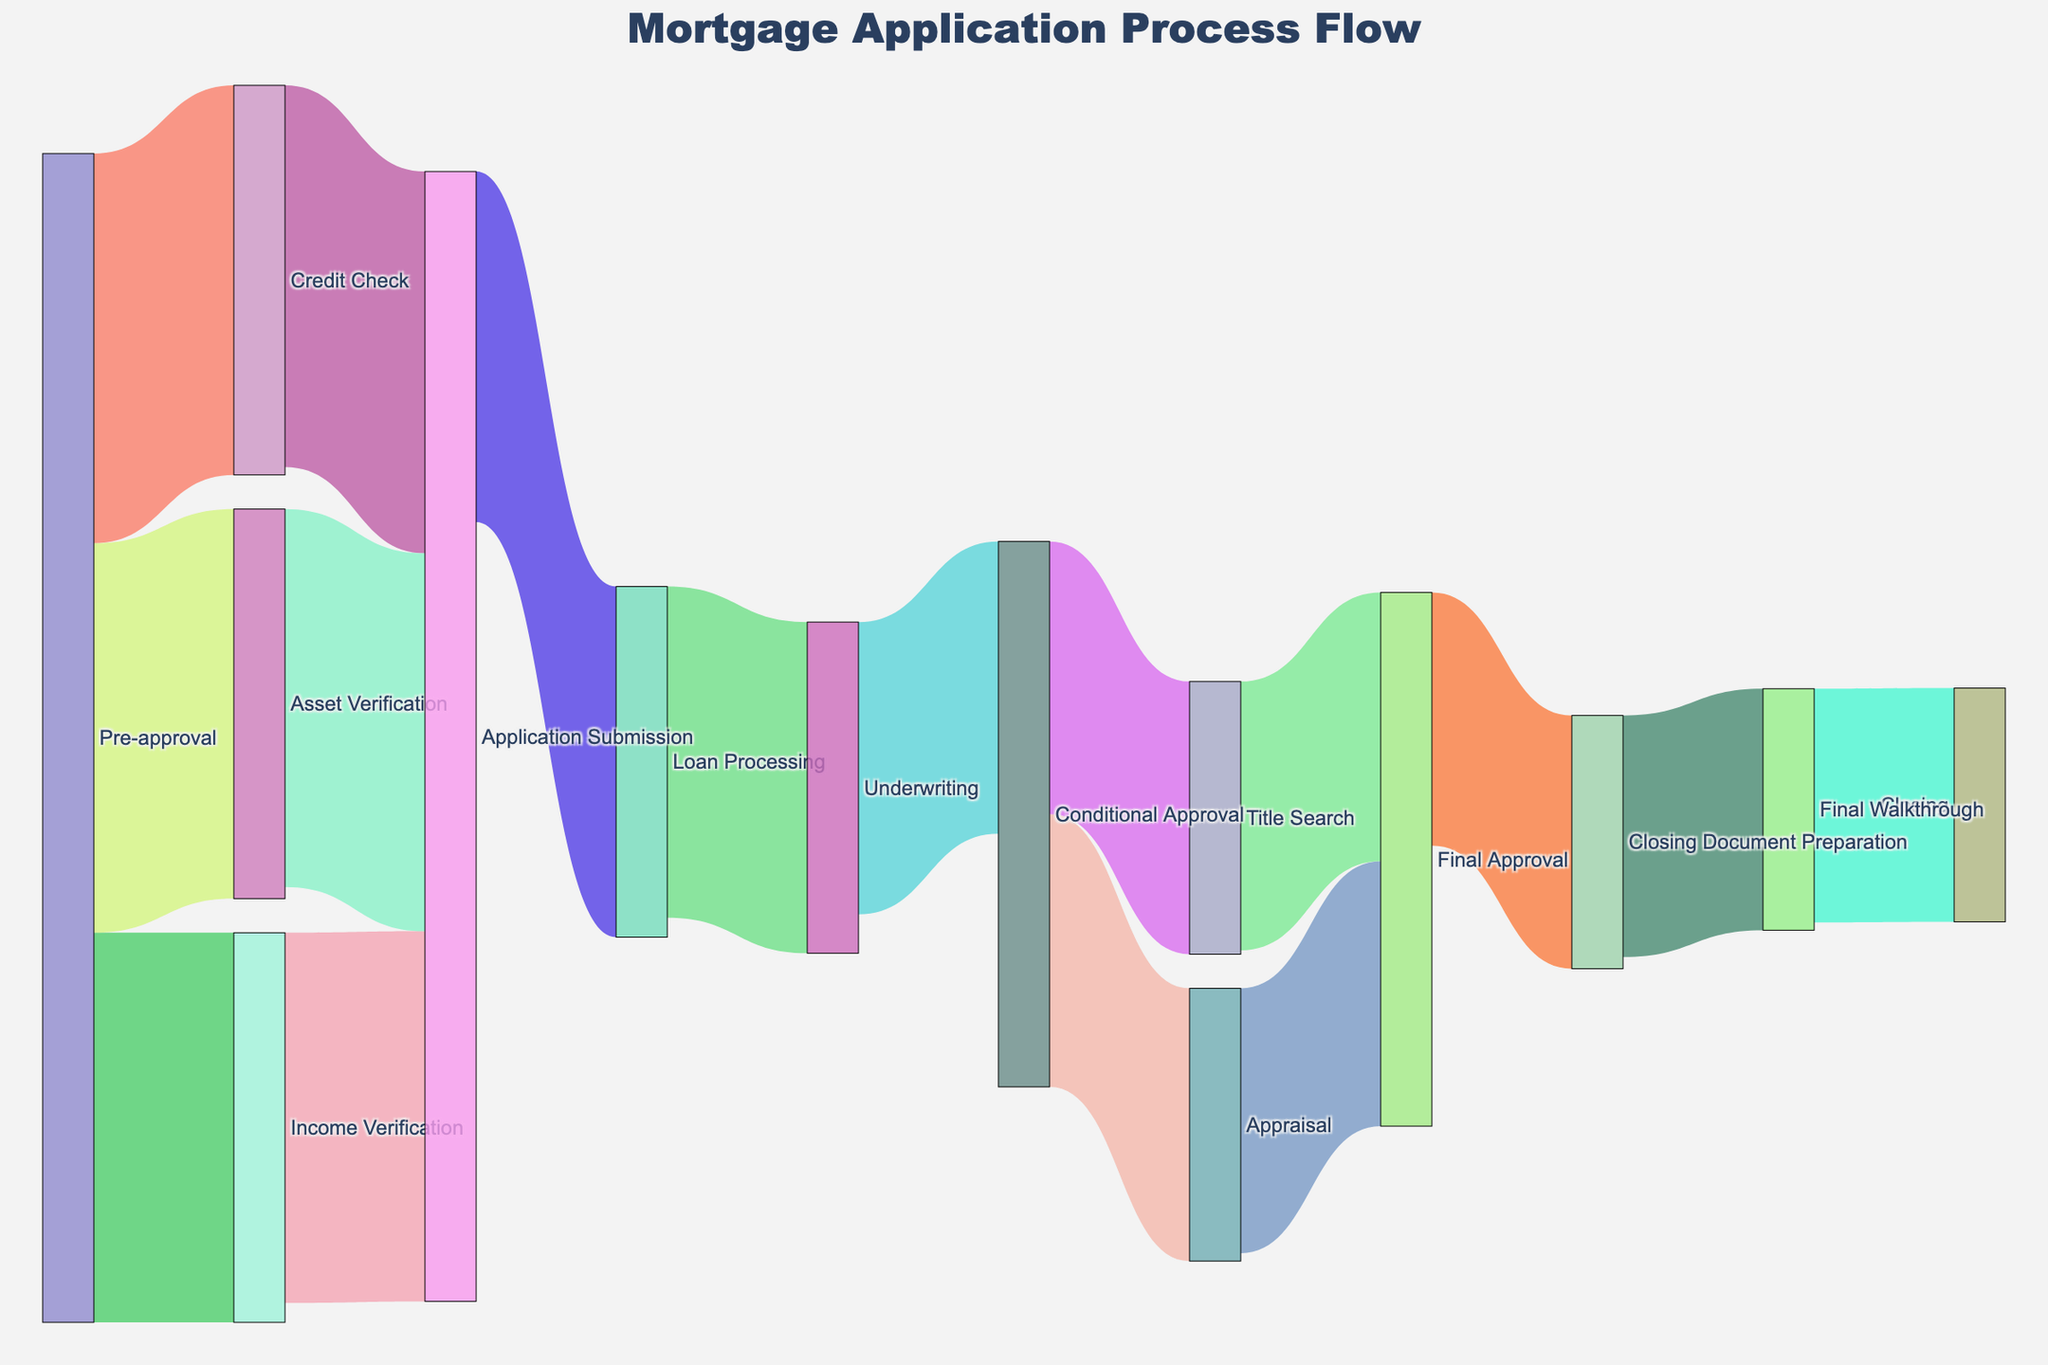what is the first stage of the mortgage application process? The first stage of the mortgage application process is labeled at the beginning of the diagram and is connected to the subsequent stages like Income Verification, Credit Check, and Asset Verification.
Answer: Pre-approval how many stages lead directly from pre-approval? We can see that three arrows directly initiate from the Pre-approval node leading to three stages: Income Verification, Credit Check, and Asset Verification.
Answer: 3 what stage follows loan processing? To find the stage that follows Loan Processing, we look at the arrow emerging from the Loan Processing node, which leads to Underwriting.
Answer: Underwriting how many applications are sent to underwriting after loan processing? The value linked between Loan Processing and Underwriting indicates the number of applications proceeding forward, shown by the value associated with the arrow connecting them.
Answer: 85 what is the final stage in the mortgage application process? The final stage can be identified by locating the endpoint of the diagram where the last arrow from Final Walkthrough points, which is Closing.
Answer: Closing which stage has the largest decrease in applicants from one step to the next? To determine this, we must compare the values moving from each stage to the subsequent one. The largest decline is from Underwriting (85) to Conditional Approval (75), which shows a decrease of 10.
Answer: Underwriting to Conditional Approval how many total applications reach the final approval stage? Applications reach Final Approval from both Appraisal and Title Search, as indicated by the arrows and values flowing into Final Approval (68 and 69 respectively). Summing these gives the total number.
Answer: 137 how do the flows into final approval compare to each other? Comparing the values of flows into Final Approval from Appraisal and Title Search, the values are 68 and 69 respectively.
Answer: Title Search flow is slightly larger than Appraisal by 1 if an application reaches conditional approval, which possible paths can it take? From Conditional Approval, it can either move to Appraisal or Title Search, as indicated by the connecting arrows.
Answer: Appraisal or Title Search how many applicants complete the final walkthrough? The value associated with the arrow flowing from Closing Document Preparation to Final Walkthrough shows the number of applications at this stage.
Answer: 62 